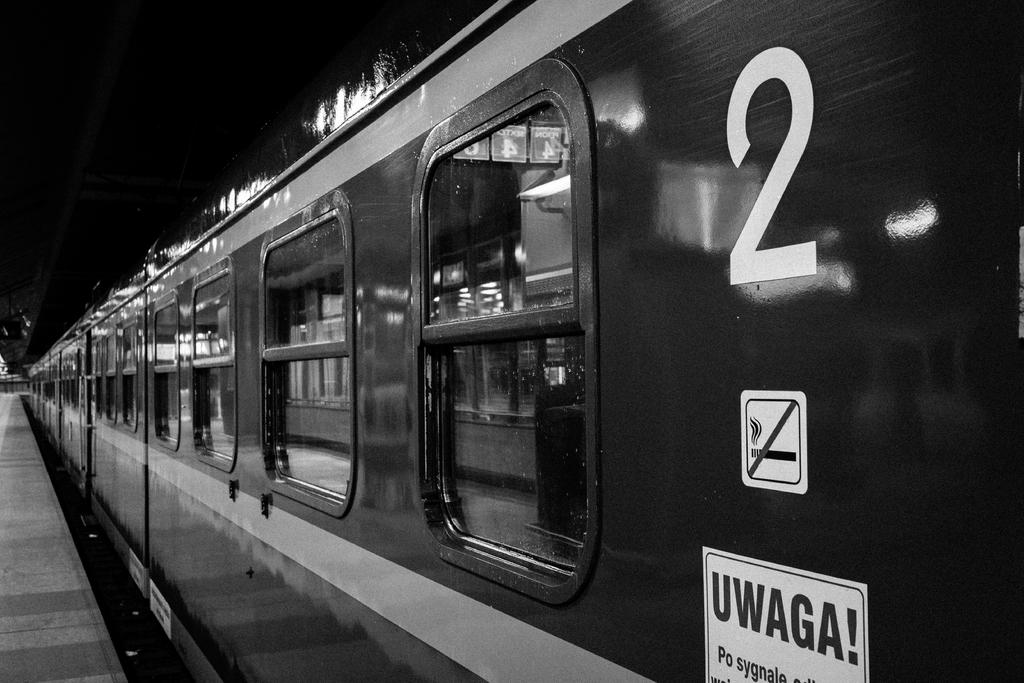Provide a one-sentence caption for the provided image. a train with the number 2 written across. 